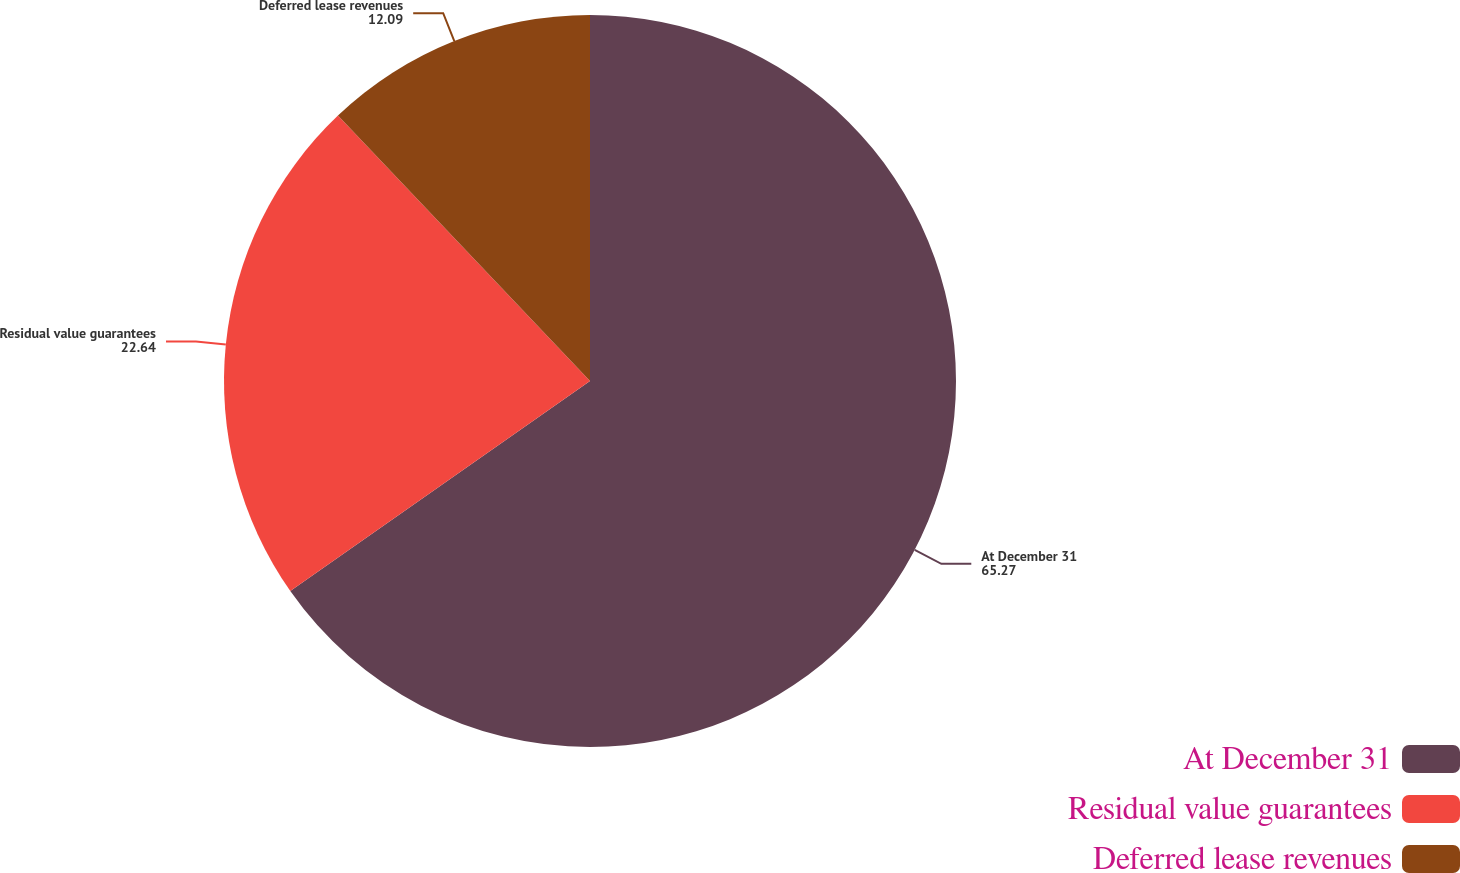Convert chart. <chart><loc_0><loc_0><loc_500><loc_500><pie_chart><fcel>At December 31<fcel>Residual value guarantees<fcel>Deferred lease revenues<nl><fcel>65.27%<fcel>22.64%<fcel>12.09%<nl></chart> 